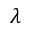Convert formula to latex. <formula><loc_0><loc_0><loc_500><loc_500>\lambda</formula> 